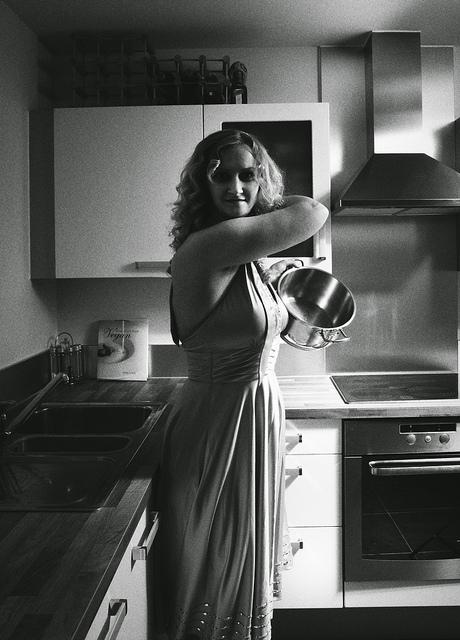Is the woman wearing an evening dress?
Short answer required. Yes. What color is the photo?
Give a very brief answer. Black and white. Is the woman going to hit someone?
Be succinct. No. 